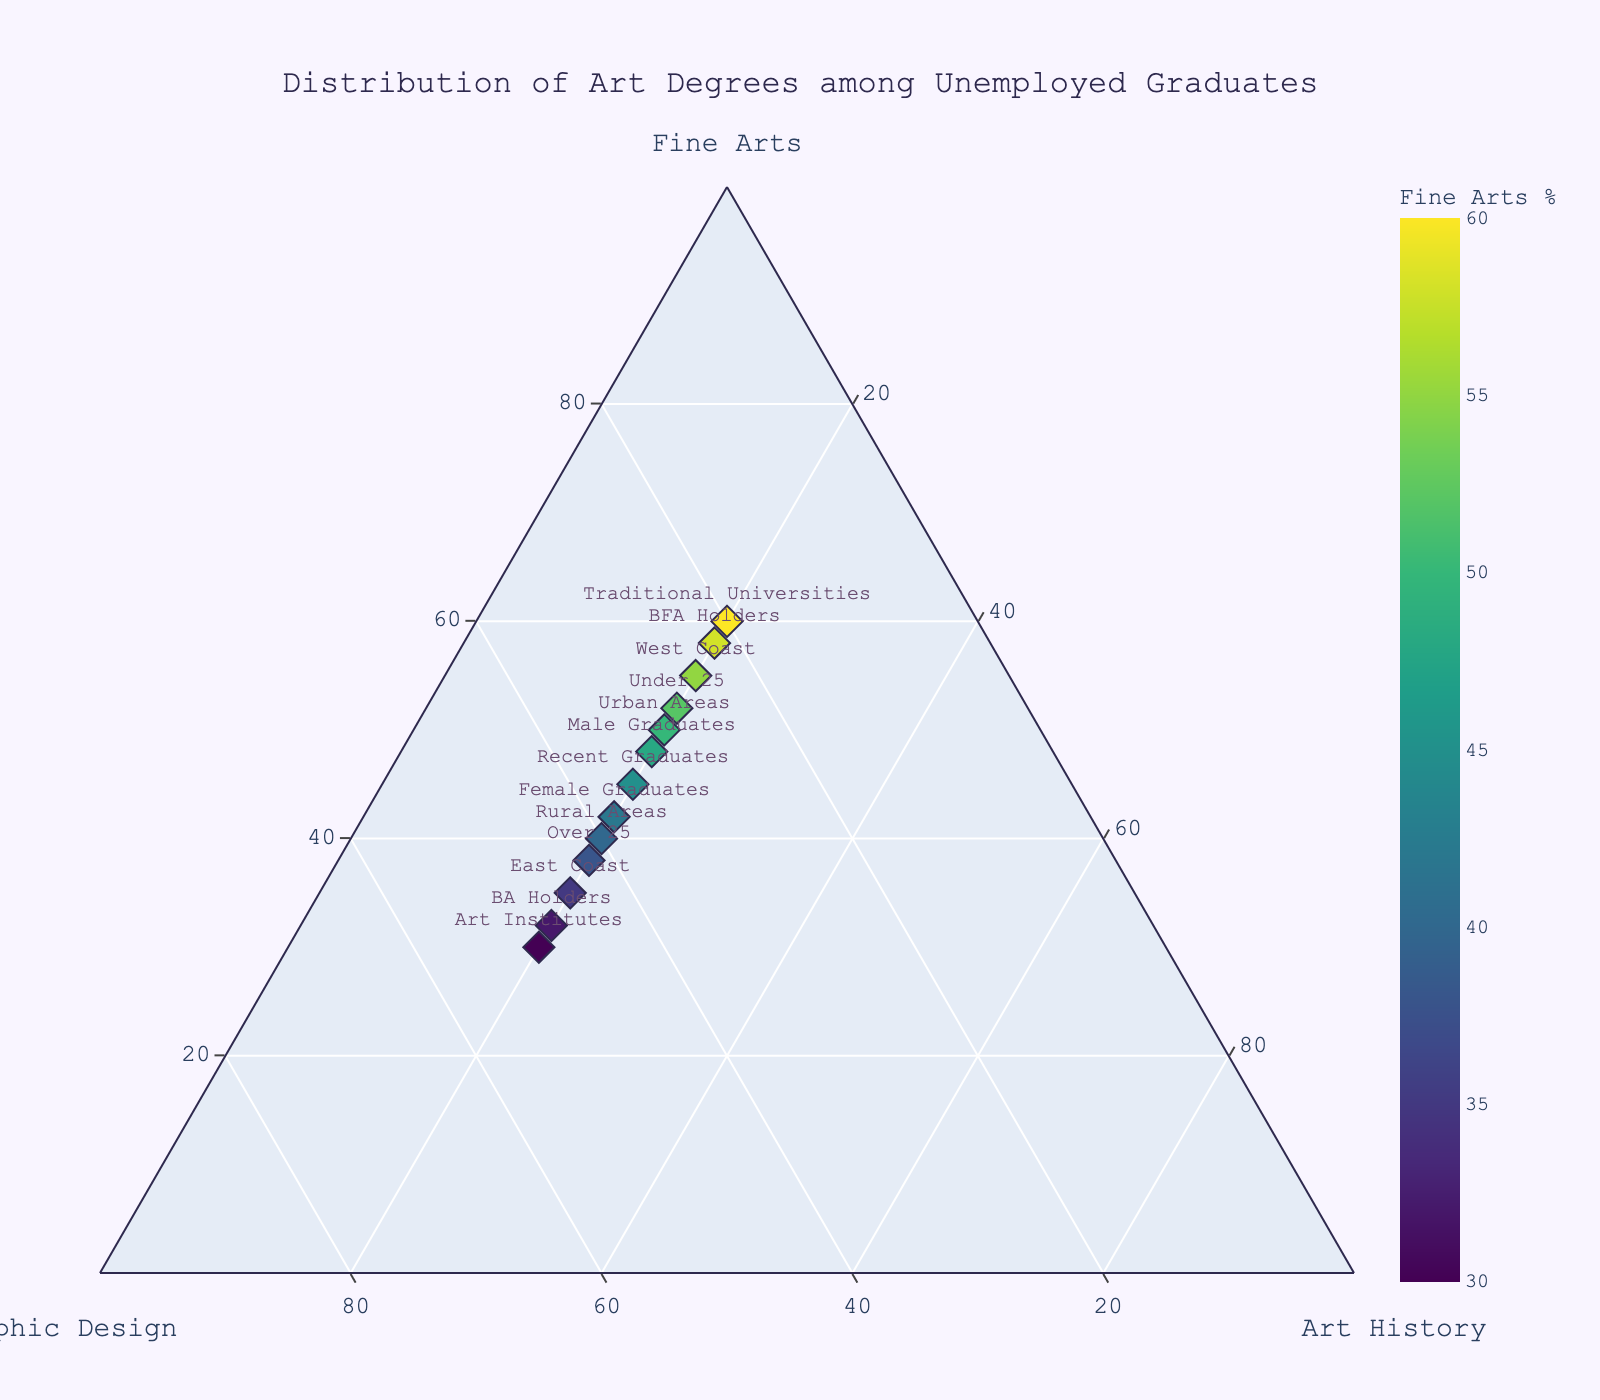What's the title of the figure? The title is typically displayed at the top of the figure and is meant to summarize the content or purpose of the visualization. Check at the top center of the figure for this information.
Answer: Distribution of Art Degrees among Unemployed Graduates How many labeled data points are there in the plot? The number of labeled data points can be determined by counting the unique labels on the plot. Each label represents a data point.
Answer: 13 Which group has the highest percentage of Fine Arts graduates? Examine the axis corresponding to Fine Arts. Identify the point that is farthest along this axis. The label of this point will indicate the group.
Answer: Traditional Universities What is the percentage distribution for 'East Coast'? Find the point labeled 'East Coast' and note its position relative to each axis. The percentage for each degree is indicated by its relative distance from the axis.
Answer: 35% Fine Arts, 45% Graphic Design, 20% Art History Which groups have the same percentage of Art History graduates? Look for all the data points and check their distances along the Art History axis. Find points that are equidistant from the Art History axis to determine the percentage.
Answer: All groups have 20% Art History graduates Which group has the most balanced distribution across Fine Arts, Graphic Design, and Art History? A balanced distribution means having percentages that are more or less equal. Identify the point closest to the center of the plot where all three axes meet.
Answer: Rural Areas Are there any groups with a higher percentage of Graphic Design graduates than Fine Arts graduates? Compare the positions of each group along the Fine Arts and Graphic Design axes. Identify those points that are closer to the Graphic Design axis than to the Fine Arts axis.
Answer: East Coast, Art Institutes, Over 25, BA Holders Between 'Urban Areas' and 'West Coast', which has a higher percentage of Fine Arts graduates? Locate the points for 'Urban Areas' and 'West Coast'. Compare their positions along the Fine Arts axis. The point farther along this axis has the higher percentage.
Answer: West Coast How does the percentage distribution for 'Male Graduates' compare to 'Female Graduates'? Compare the positions of the points labeled 'Male Graduates' and 'Female Graduates' on each axis. Note the percentages for Fine Arts, Graphic Design, and Art History.
Answer: Male Graduates: 48% Fine Arts, 32% Graphic Design, 20% Art History; Female Graduates: 42% Fine Arts, 38% Graphic Design, 20% Art History What is the average percentage of Fine Arts graduates across all groups? Add up the Fine Arts percentages for all groups and divide by the number of groups to get the average. (45+50+40+55+35+60+30+48+42+52+38+58+32) / 13
Answer: 46% 